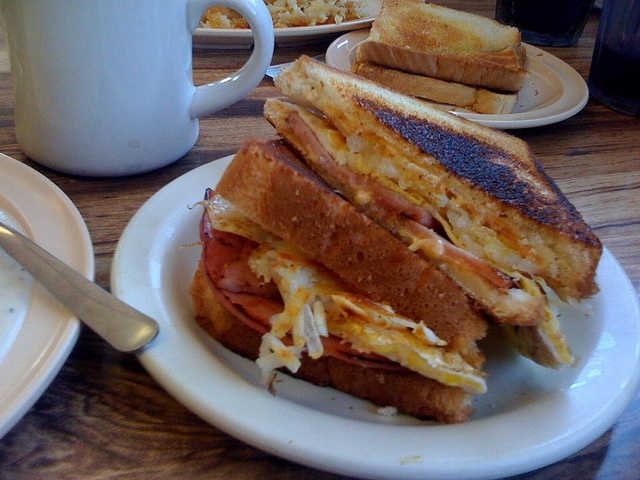Describe the objects in this image and their specific colors. I can see dining table in maroon, black, gray, and darkgray tones, sandwich in gray, maroon, brown, and black tones, sandwich in gray, brown, maroon, and tan tones, cup in gray and darkgray tones, and sandwich in gray, olive, and maroon tones in this image. 